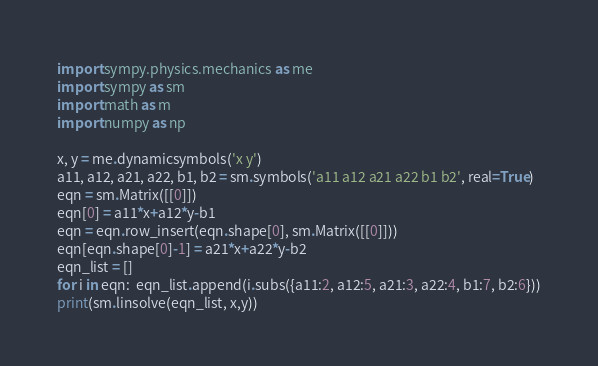Convert code to text. <code><loc_0><loc_0><loc_500><loc_500><_Python_>import sympy.physics.mechanics as me
import sympy as sm
import math as m
import numpy as np

x, y = me.dynamicsymbols('x y')
a11, a12, a21, a22, b1, b2 = sm.symbols('a11 a12 a21 a22 b1 b2', real=True)
eqn = sm.Matrix([[0]])
eqn[0] = a11*x+a12*y-b1
eqn = eqn.row_insert(eqn.shape[0], sm.Matrix([[0]]))
eqn[eqn.shape[0]-1] = a21*x+a22*y-b2
eqn_list = []
for i in eqn:  eqn_list.append(i.subs({a11:2, a12:5, a21:3, a22:4, b1:7, b2:6}))
print(sm.linsolve(eqn_list, x,y))
</code> 